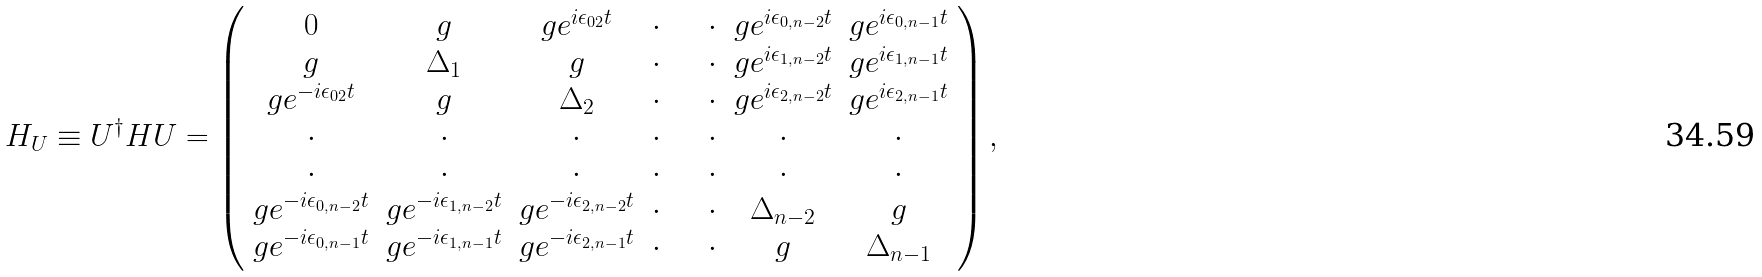<formula> <loc_0><loc_0><loc_500><loc_500>H _ { U } \equiv U ^ { \dagger } H U = \left ( \begin{array} { c c c c c c c } 0 & g & g e ^ { i \epsilon _ { 0 2 } t } & \cdot & \quad \cdot & g e ^ { i \epsilon _ { 0 , n - 2 } t } & g e ^ { i \epsilon _ { 0 , n - 1 } t } \\ g & \Delta _ { 1 } & g & \cdot & \quad \cdot & g e ^ { i \epsilon _ { 1 , n - 2 } t } & g e ^ { i \epsilon _ { 1 , n - 1 } t } \\ g e ^ { - i \epsilon _ { 0 2 } t } & g & \Delta _ { 2 } & \cdot & \quad \cdot & g e ^ { i \epsilon _ { 2 , n - 2 } t } & g e ^ { i \epsilon _ { 2 , n - 1 } t } \\ \cdot & \cdot & \cdot & \cdot & \quad \cdot & \cdot & \cdot \\ \cdot & \cdot & \cdot & \cdot & \quad \cdot & \cdot & \cdot \\ g e ^ { - i \epsilon _ { 0 , n - 2 } t } & g e ^ { - i \epsilon _ { 1 , n - 2 } t } & g e ^ { - i \epsilon _ { 2 , n - 2 } t } & \cdot & \quad \cdot & \Delta _ { n - 2 } & g \\ g e ^ { - i \epsilon _ { 0 , n - 1 } t } & g e ^ { - i \epsilon _ { 1 , n - 1 } t } & g e ^ { - i \epsilon _ { 2 , n - 1 } t } & \cdot & \quad \cdot & g & \Delta _ { n - 1 } \end{array} \right ) ,</formula> 